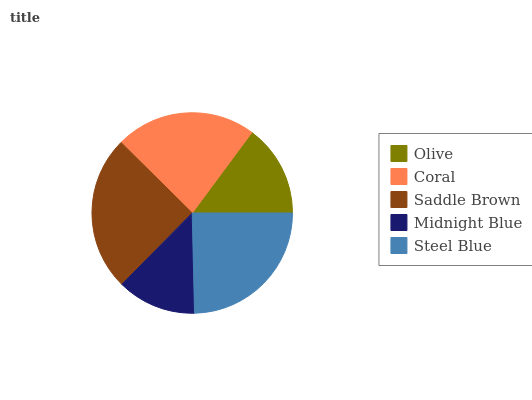Is Midnight Blue the minimum?
Answer yes or no. Yes. Is Saddle Brown the maximum?
Answer yes or no. Yes. Is Coral the minimum?
Answer yes or no. No. Is Coral the maximum?
Answer yes or no. No. Is Coral greater than Olive?
Answer yes or no. Yes. Is Olive less than Coral?
Answer yes or no. Yes. Is Olive greater than Coral?
Answer yes or no. No. Is Coral less than Olive?
Answer yes or no. No. Is Coral the high median?
Answer yes or no. Yes. Is Coral the low median?
Answer yes or no. Yes. Is Midnight Blue the high median?
Answer yes or no. No. Is Midnight Blue the low median?
Answer yes or no. No. 